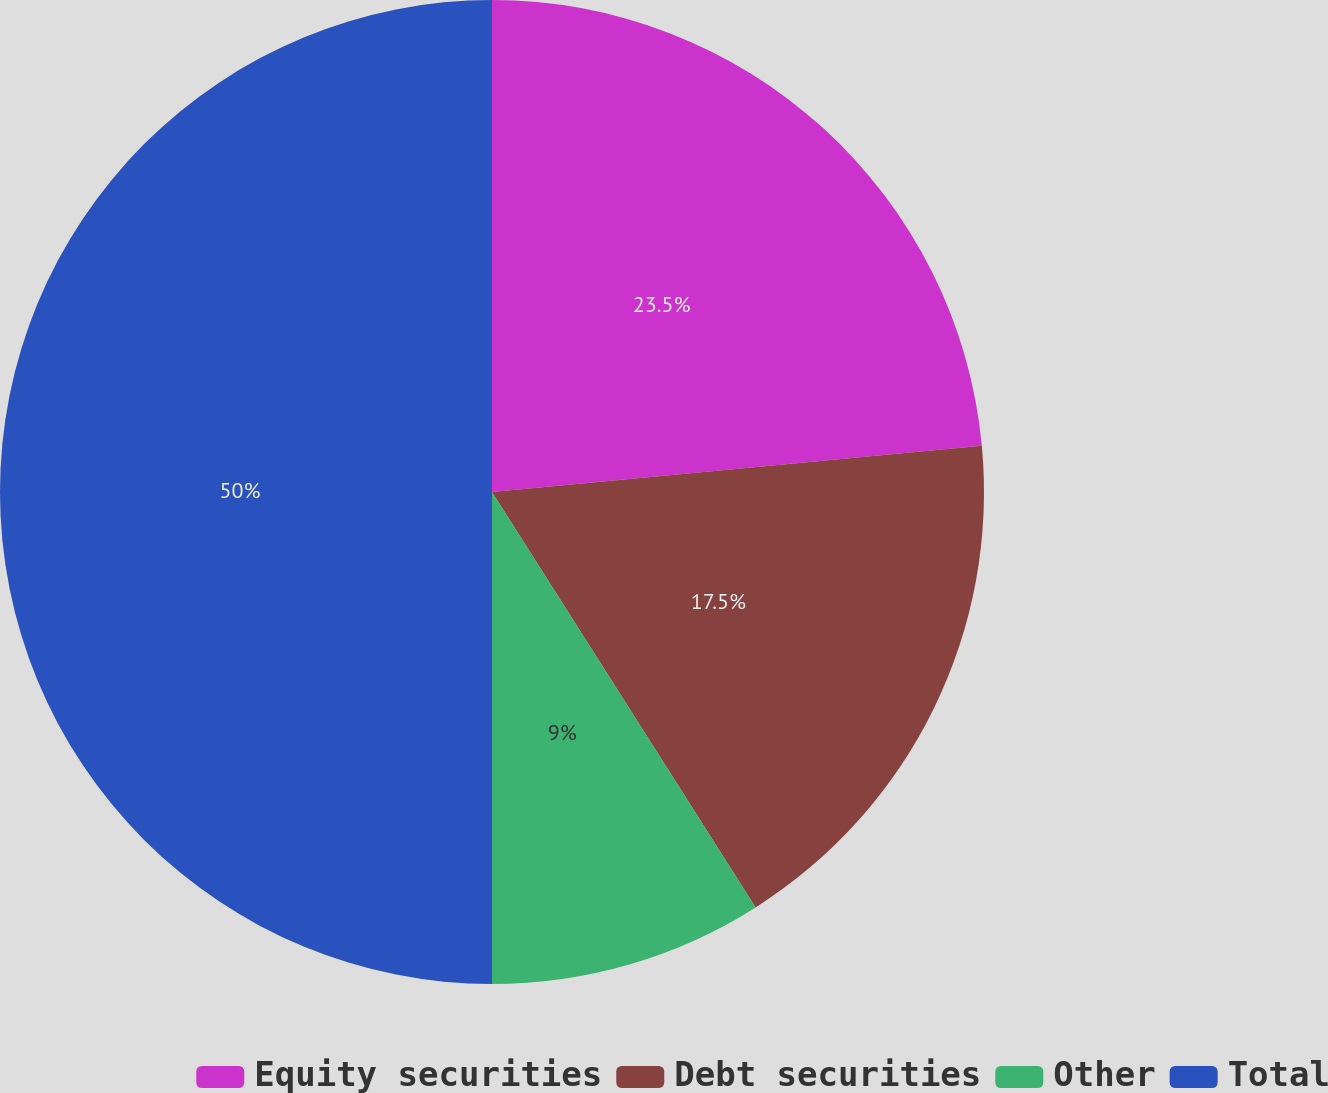Convert chart to OTSL. <chart><loc_0><loc_0><loc_500><loc_500><pie_chart><fcel>Equity securities<fcel>Debt securities<fcel>Other<fcel>Total<nl><fcel>23.5%<fcel>17.5%<fcel>9.0%<fcel>50.0%<nl></chart> 